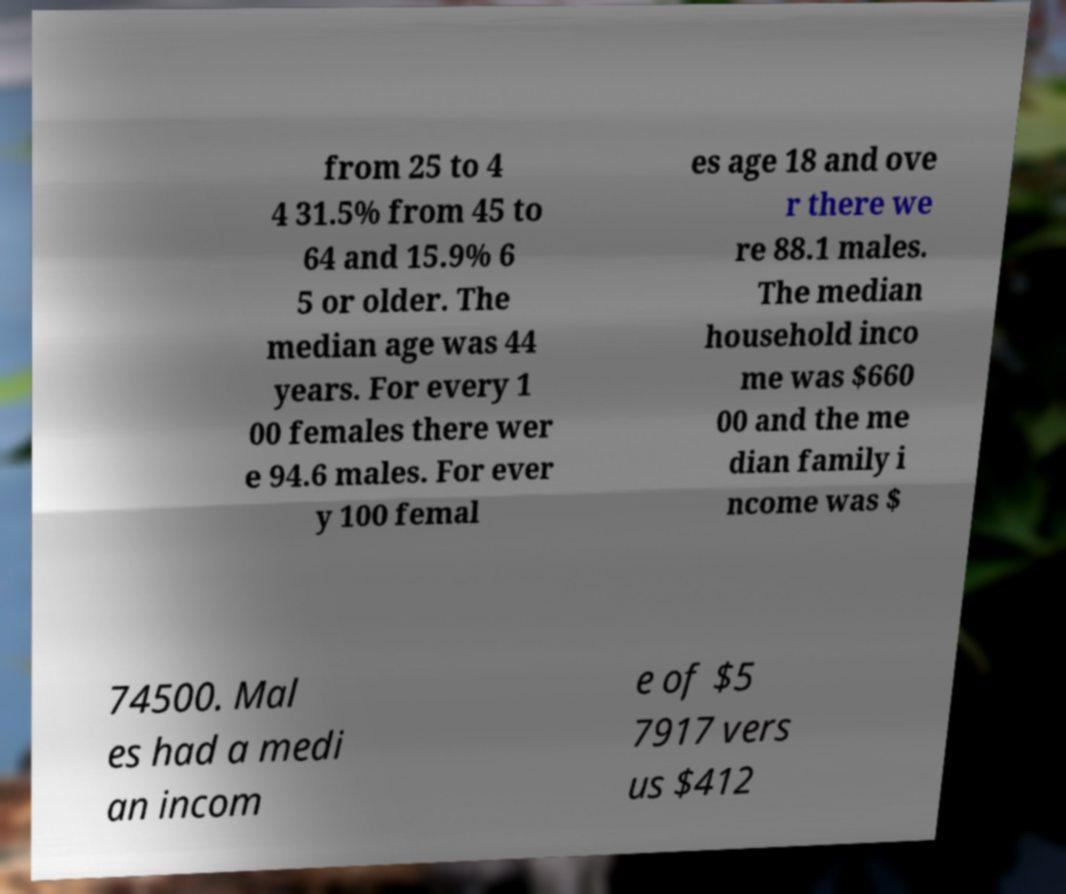Could you assist in decoding the text presented in this image and type it out clearly? from 25 to 4 4 31.5% from 45 to 64 and 15.9% 6 5 or older. The median age was 44 years. For every 1 00 females there wer e 94.6 males. For ever y 100 femal es age 18 and ove r there we re 88.1 males. The median household inco me was $660 00 and the me dian family i ncome was $ 74500. Mal es had a medi an incom e of $5 7917 vers us $412 